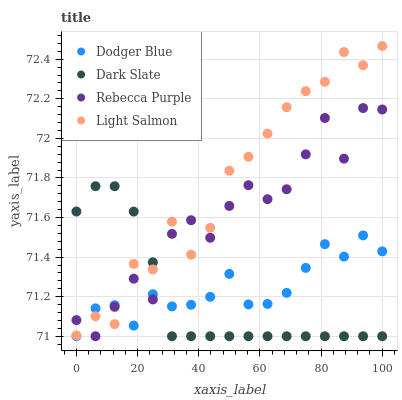Does Dark Slate have the minimum area under the curve?
Answer yes or no. Yes. Does Light Salmon have the maximum area under the curve?
Answer yes or no. Yes. Does Dodger Blue have the minimum area under the curve?
Answer yes or no. No. Does Dodger Blue have the maximum area under the curve?
Answer yes or no. No. Is Dark Slate the smoothest?
Answer yes or no. Yes. Is Rebecca Purple the roughest?
Answer yes or no. Yes. Is Light Salmon the smoothest?
Answer yes or no. No. Is Light Salmon the roughest?
Answer yes or no. No. Does Dark Slate have the lowest value?
Answer yes or no. Yes. Does Light Salmon have the lowest value?
Answer yes or no. No. Does Light Salmon have the highest value?
Answer yes or no. Yes. Does Dodger Blue have the highest value?
Answer yes or no. No. Does Light Salmon intersect Rebecca Purple?
Answer yes or no. Yes. Is Light Salmon less than Rebecca Purple?
Answer yes or no. No. Is Light Salmon greater than Rebecca Purple?
Answer yes or no. No. 